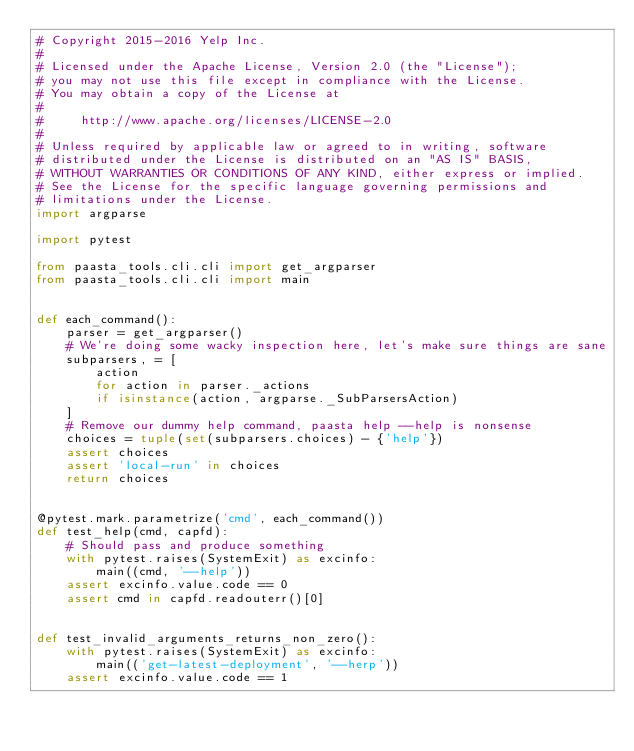<code> <loc_0><loc_0><loc_500><loc_500><_Python_># Copyright 2015-2016 Yelp Inc.
#
# Licensed under the Apache License, Version 2.0 (the "License");
# you may not use this file except in compliance with the License.
# You may obtain a copy of the License at
#
#     http://www.apache.org/licenses/LICENSE-2.0
#
# Unless required by applicable law or agreed to in writing, software
# distributed under the License is distributed on an "AS IS" BASIS,
# WITHOUT WARRANTIES OR CONDITIONS OF ANY KIND, either express or implied.
# See the License for the specific language governing permissions and
# limitations under the License.
import argparse

import pytest

from paasta_tools.cli.cli import get_argparser
from paasta_tools.cli.cli import main


def each_command():
    parser = get_argparser()
    # We're doing some wacky inspection here, let's make sure things are sane
    subparsers, = [
        action
        for action in parser._actions
        if isinstance(action, argparse._SubParsersAction)
    ]
    # Remove our dummy help command, paasta help --help is nonsense
    choices = tuple(set(subparsers.choices) - {'help'})
    assert choices
    assert 'local-run' in choices
    return choices


@pytest.mark.parametrize('cmd', each_command())
def test_help(cmd, capfd):
    # Should pass and produce something
    with pytest.raises(SystemExit) as excinfo:
        main((cmd, '--help'))
    assert excinfo.value.code == 0
    assert cmd in capfd.readouterr()[0]


def test_invalid_arguments_returns_non_zero():
    with pytest.raises(SystemExit) as excinfo:
        main(('get-latest-deployment', '--herp'))
    assert excinfo.value.code == 1
</code> 